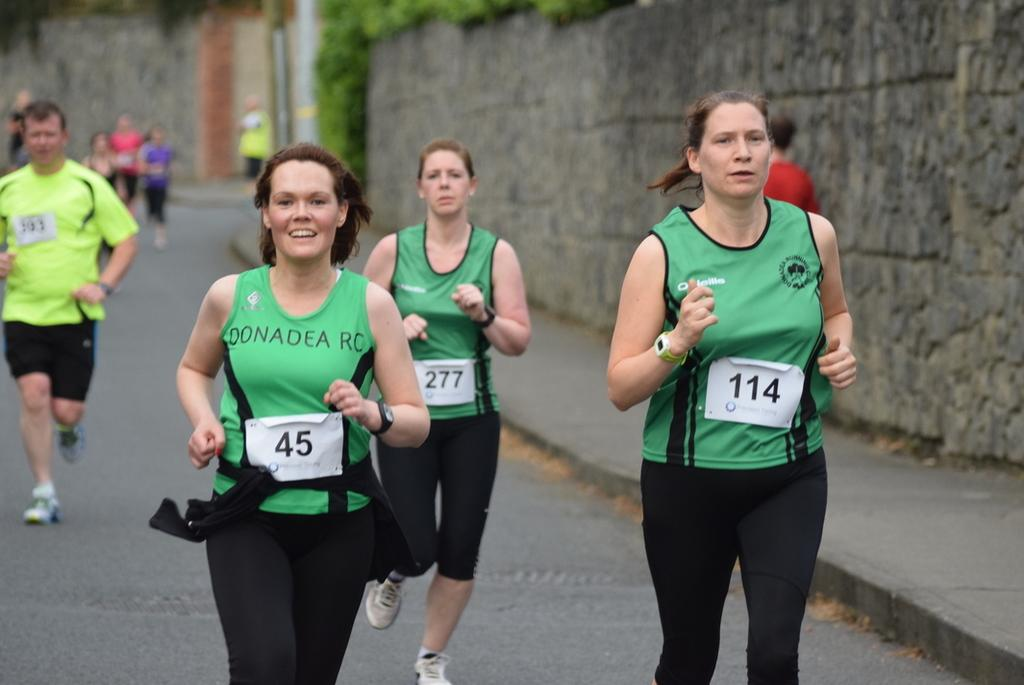<image>
Share a concise interpretation of the image provided. a woman in a green jersey with the number 45 running a race 